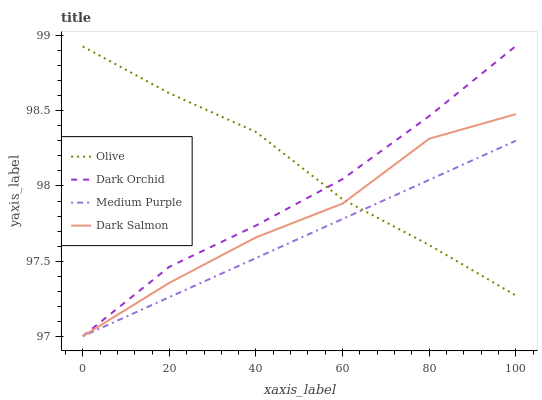Does Medium Purple have the minimum area under the curve?
Answer yes or no. Yes. Does Olive have the maximum area under the curve?
Answer yes or no. Yes. Does Dark Salmon have the minimum area under the curve?
Answer yes or no. No. Does Dark Salmon have the maximum area under the curve?
Answer yes or no. No. Is Medium Purple the smoothest?
Answer yes or no. Yes. Is Dark Salmon the roughest?
Answer yes or no. Yes. Is Dark Salmon the smoothest?
Answer yes or no. No. Is Medium Purple the roughest?
Answer yes or no. No. Does Medium Purple have the lowest value?
Answer yes or no. Yes. Does Dark Orchid have the highest value?
Answer yes or no. Yes. Does Dark Salmon have the highest value?
Answer yes or no. No. Does Medium Purple intersect Dark Salmon?
Answer yes or no. Yes. Is Medium Purple less than Dark Salmon?
Answer yes or no. No. Is Medium Purple greater than Dark Salmon?
Answer yes or no. No. 